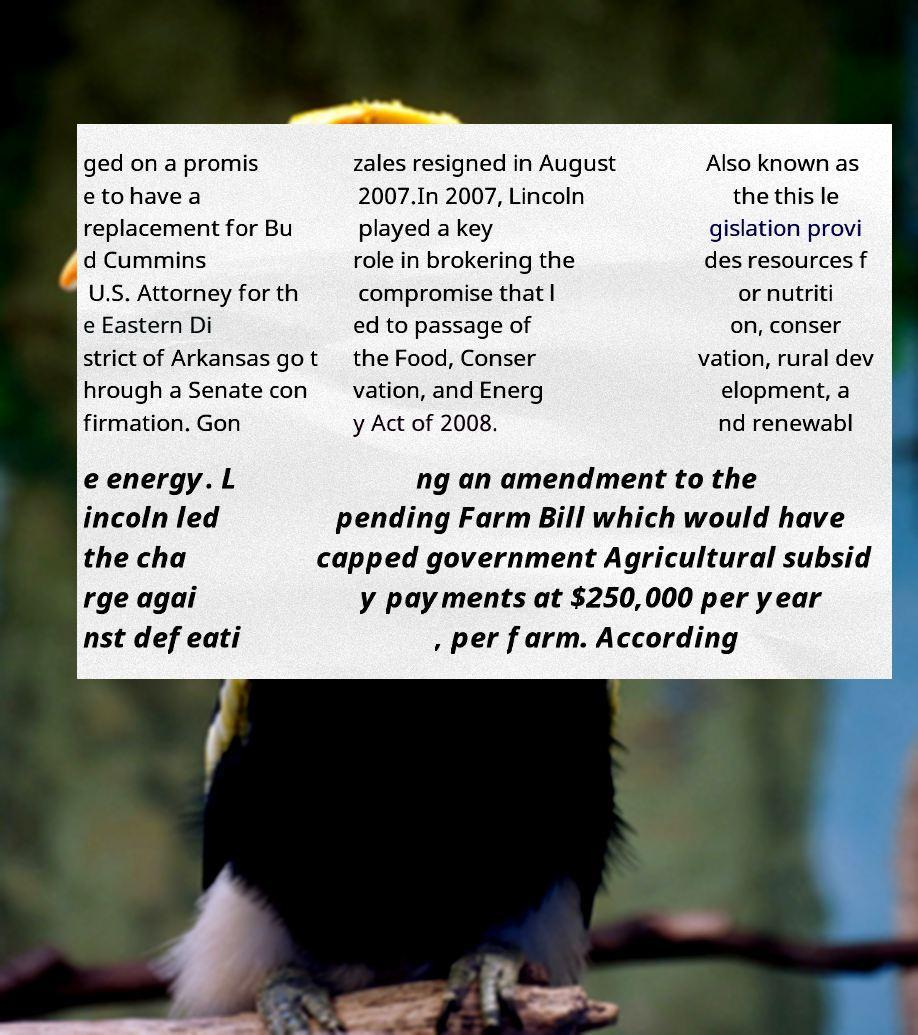For documentation purposes, I need the text within this image transcribed. Could you provide that? ged on a promis e to have a replacement for Bu d Cummins U.S. Attorney for th e Eastern Di strict of Arkansas go t hrough a Senate con firmation. Gon zales resigned in August 2007.In 2007, Lincoln played a key role in brokering the compromise that l ed to passage of the Food, Conser vation, and Energ y Act of 2008. Also known as the this le gislation provi des resources f or nutriti on, conser vation, rural dev elopment, a nd renewabl e energy. L incoln led the cha rge agai nst defeati ng an amendment to the pending Farm Bill which would have capped government Agricultural subsid y payments at $250,000 per year , per farm. According 